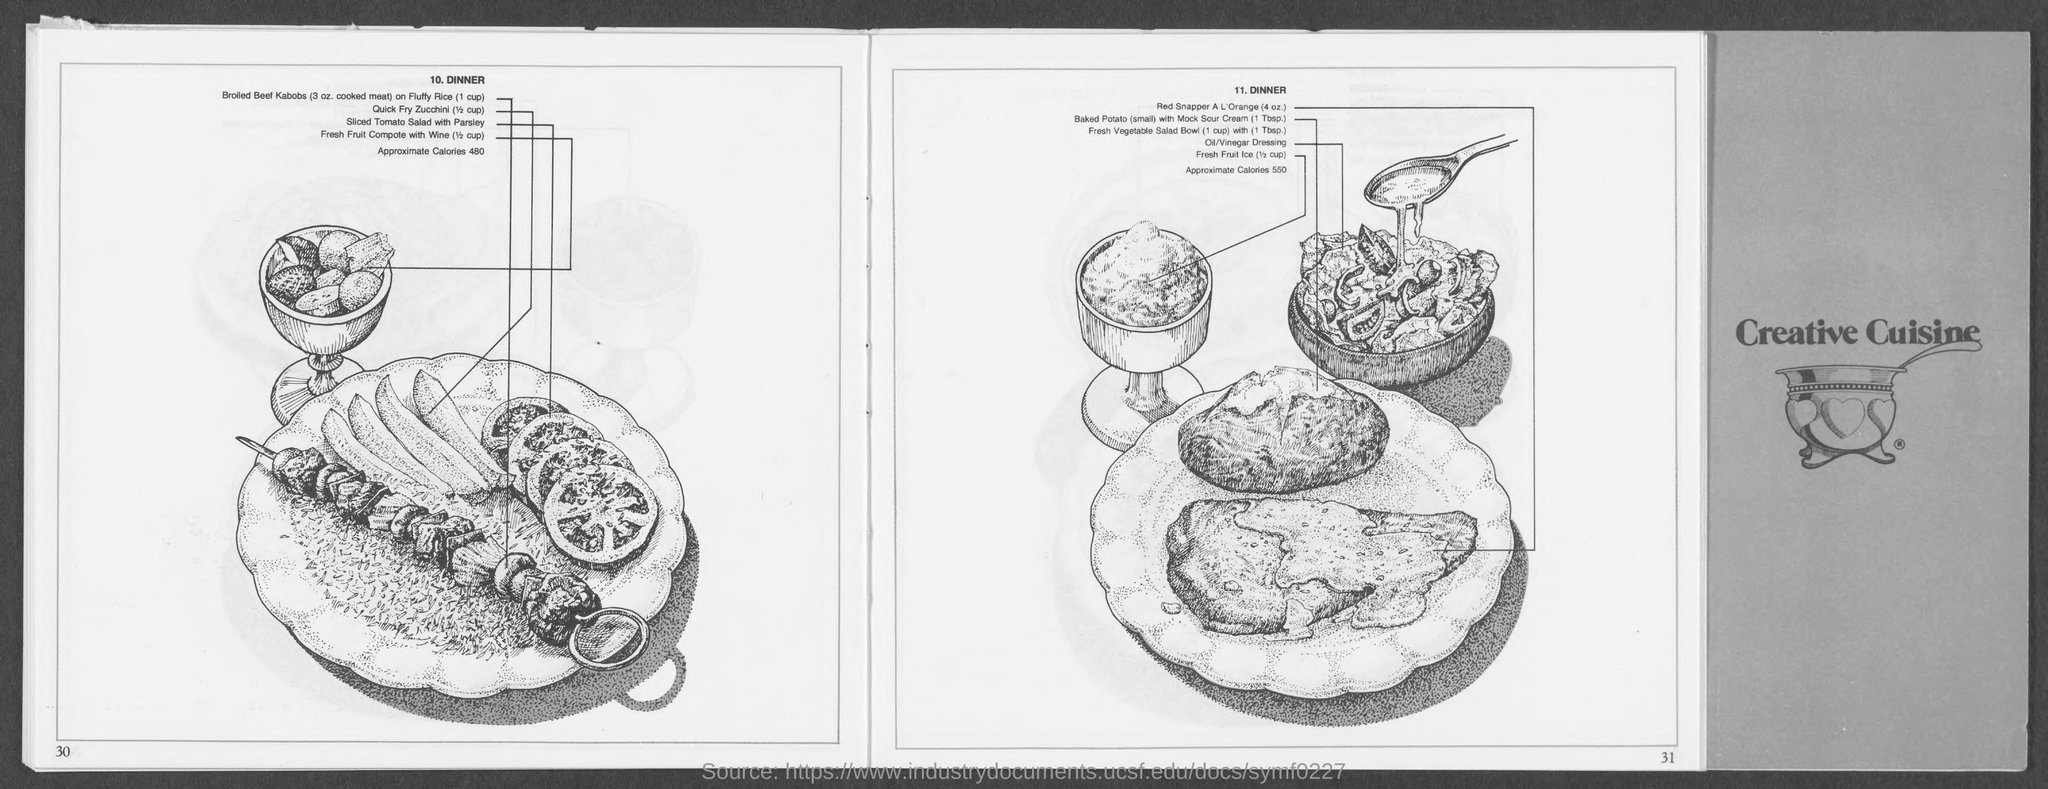What is the name of number 10.?
Offer a terse response. Dinner. 